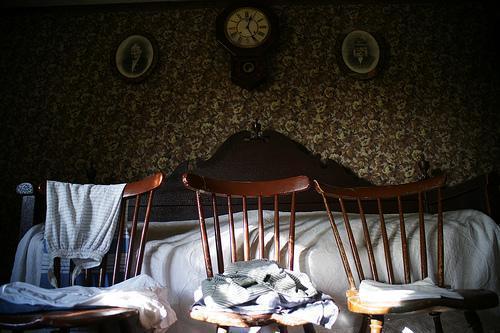How many chairs are there?
Give a very brief answer. 3. 